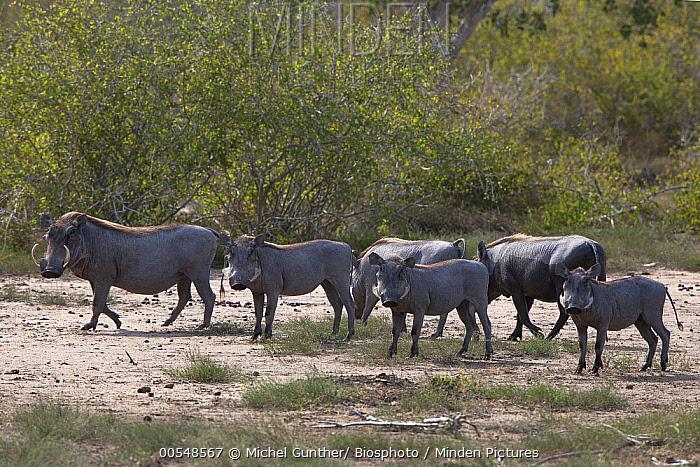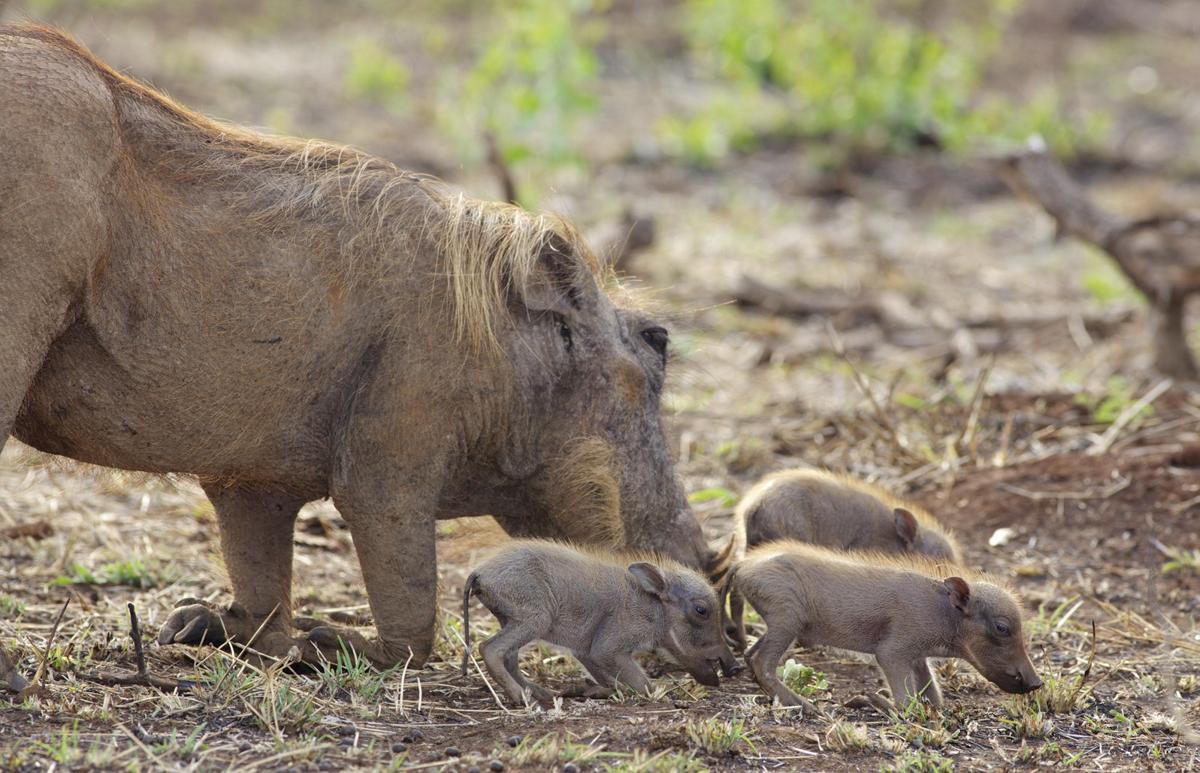The first image is the image on the left, the second image is the image on the right. Given the left and right images, does the statement "One image includes a predator of the warthog." hold true? Answer yes or no. No. The first image is the image on the left, the second image is the image on the right. Given the left and right images, does the statement "there are three baby animals in the image on the right" hold true? Answer yes or no. Yes. 